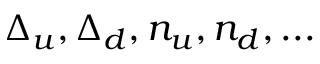<formula> <loc_0><loc_0><loc_500><loc_500>\Delta _ { u } , \Delta _ { d } , n _ { u } , n _ { d } , \dots</formula> 